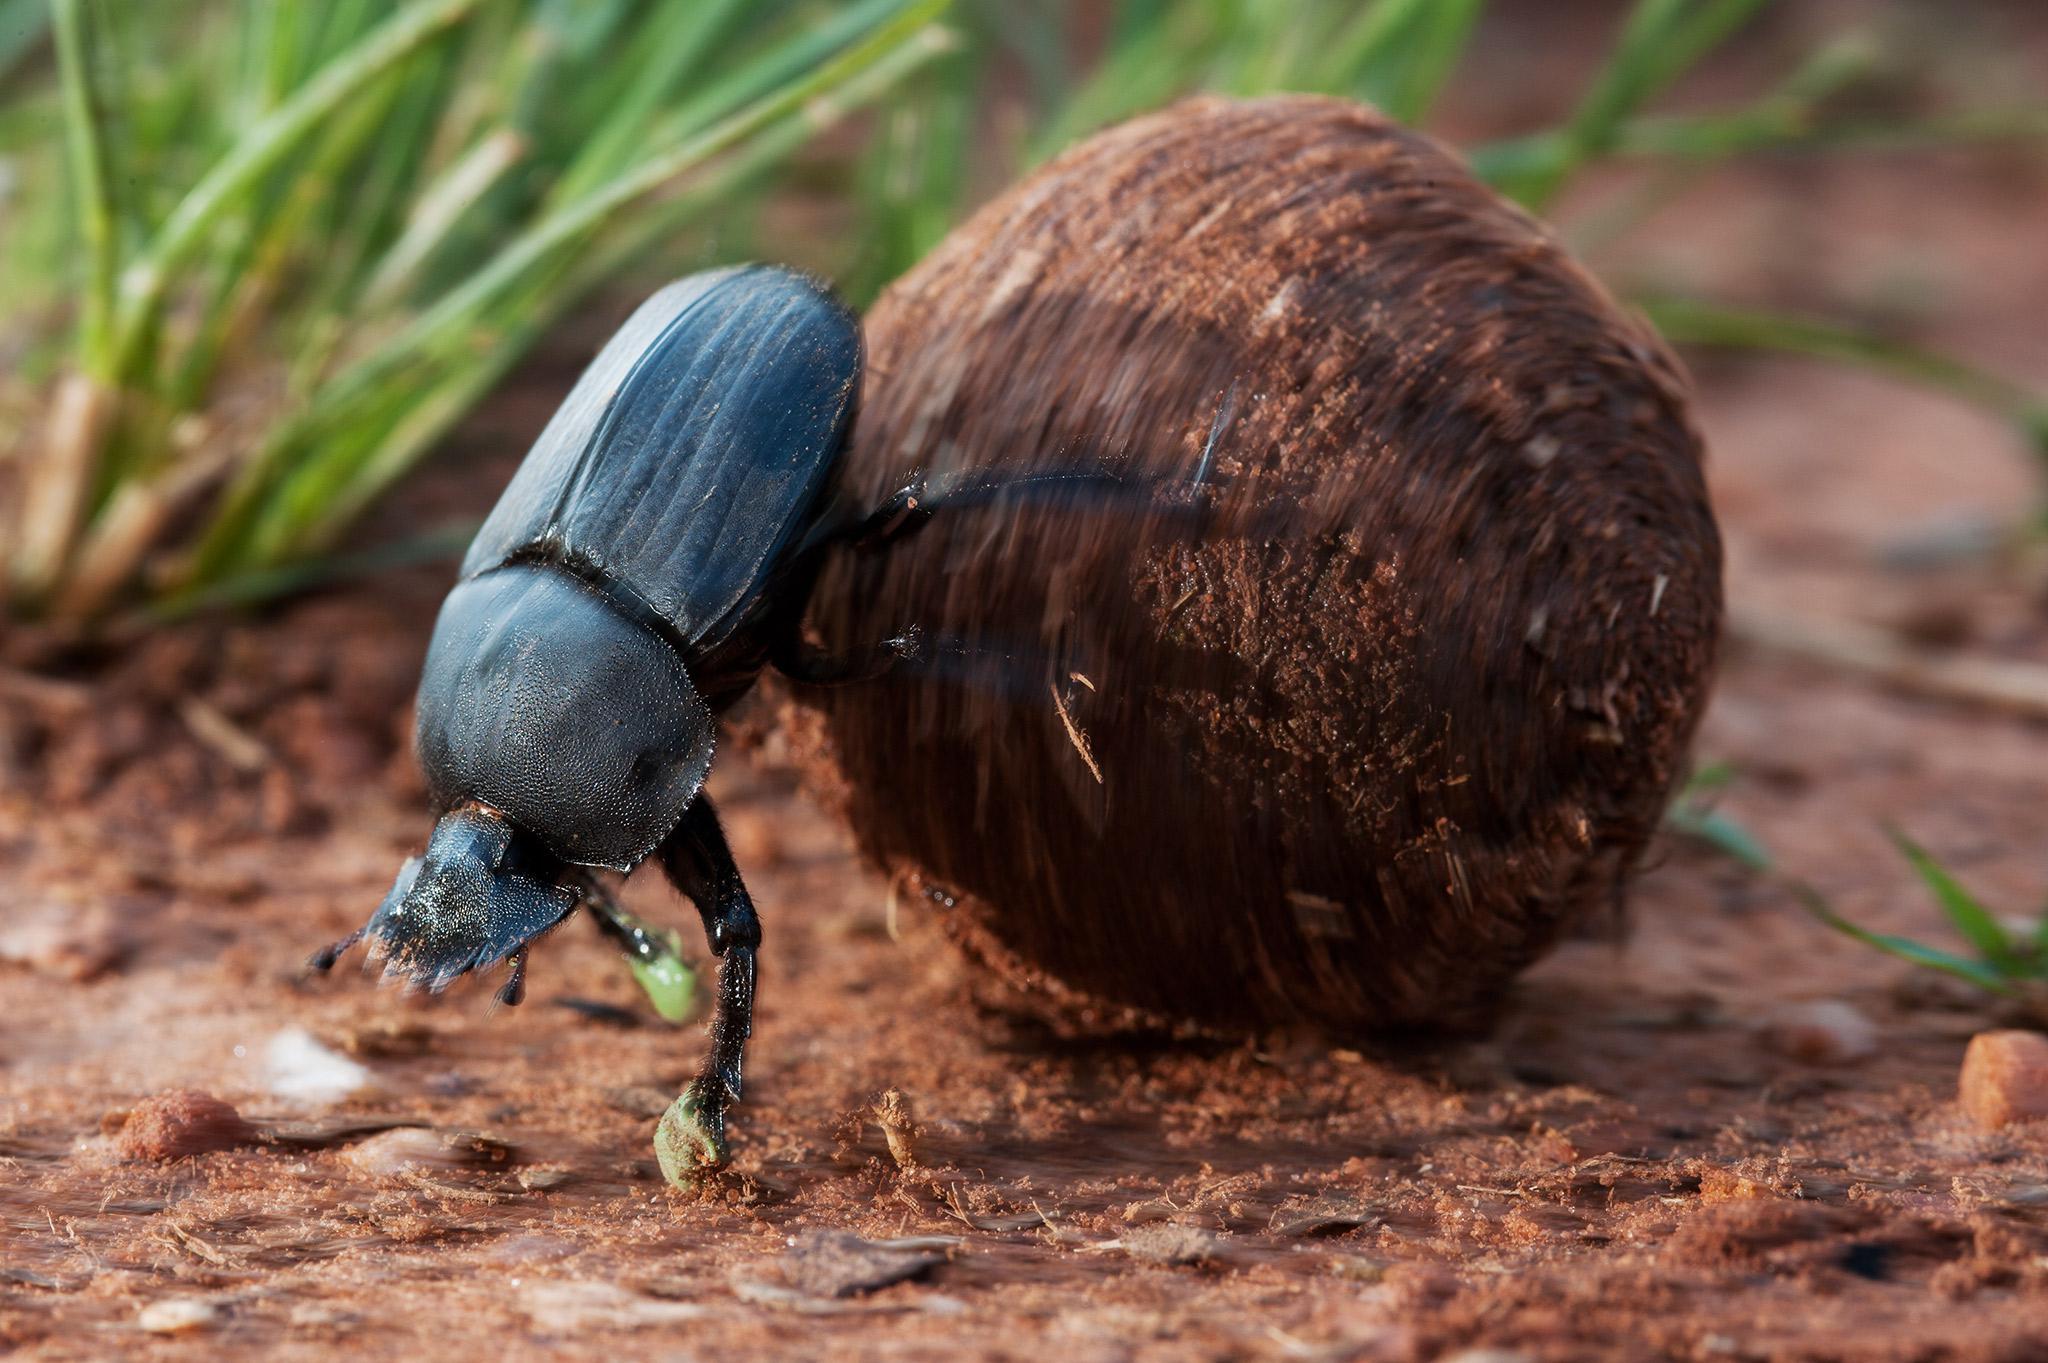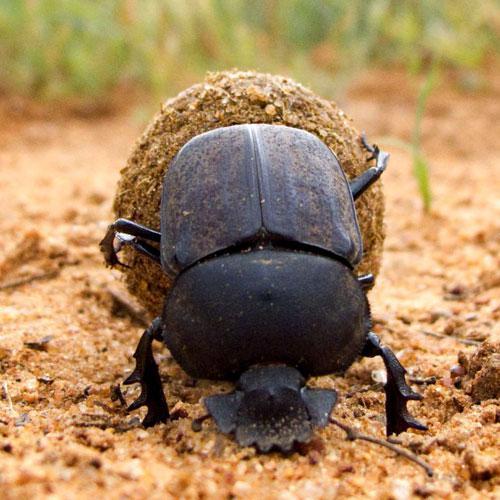The first image is the image on the left, the second image is the image on the right. Assess this claim about the two images: "Each image shows just one beetle in contact with one round dung ball.". Correct or not? Answer yes or no. Yes. The first image is the image on the left, the second image is the image on the right. Analyze the images presented: Is the assertion "One of the beetles is not on a clod of dirt." valid? Answer yes or no. No. 